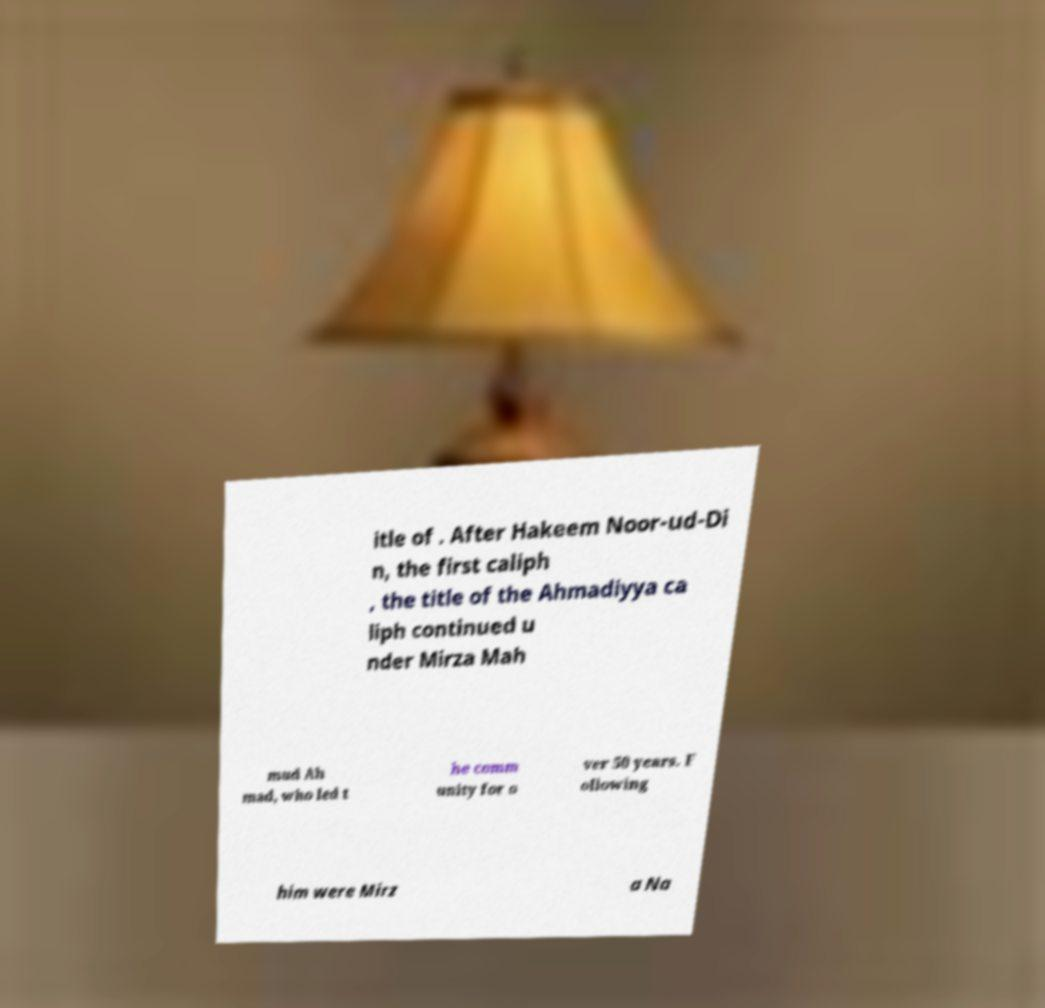Could you assist in decoding the text presented in this image and type it out clearly? itle of . After Hakeem Noor-ud-Di n, the first caliph , the title of the Ahmadiyya ca liph continued u nder Mirza Mah mud Ah mad, who led t he comm unity for o ver 50 years. F ollowing him were Mirz a Na 